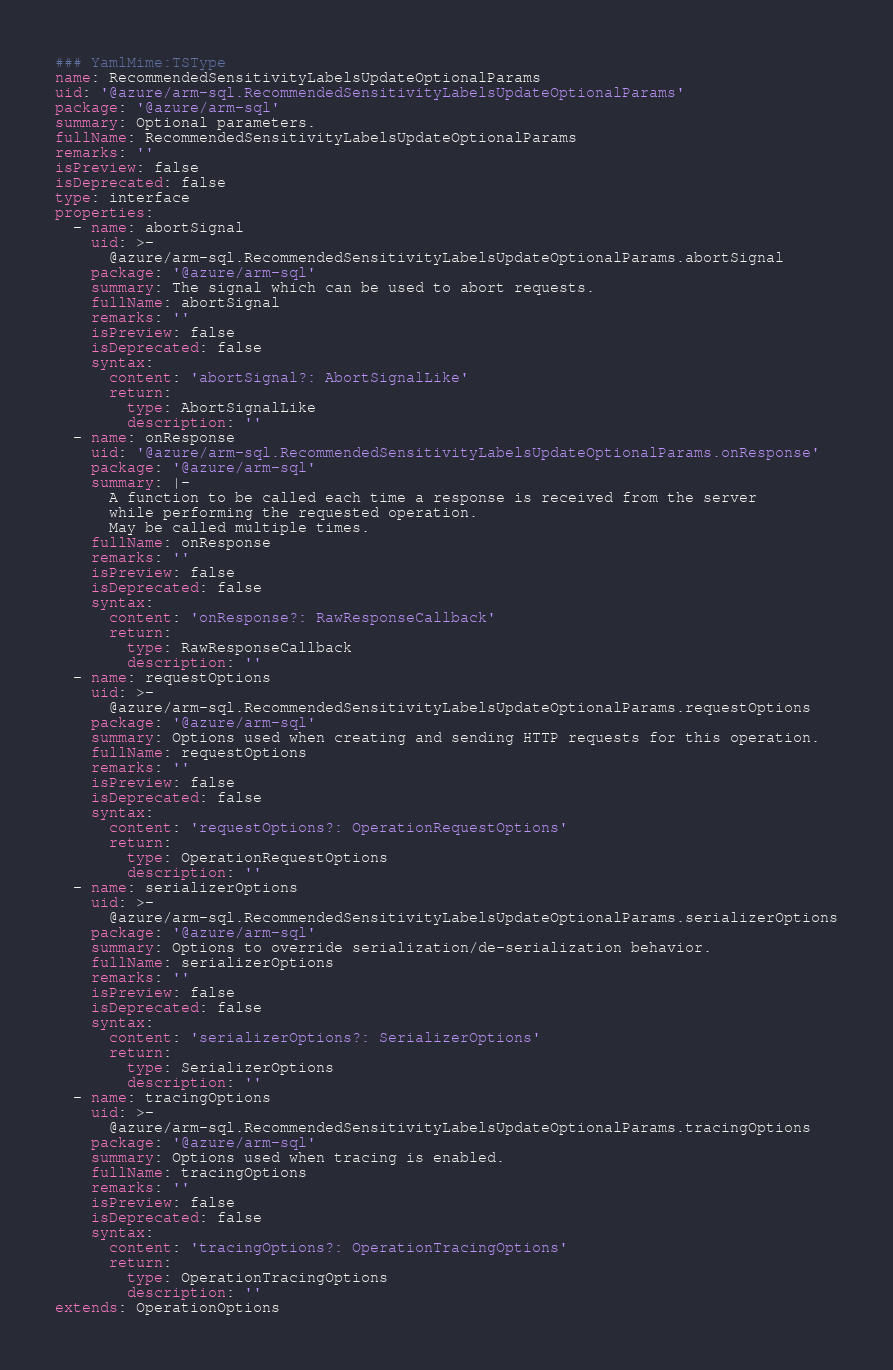<code> <loc_0><loc_0><loc_500><loc_500><_YAML_>### YamlMime:TSType
name: RecommendedSensitivityLabelsUpdateOptionalParams
uid: '@azure/arm-sql.RecommendedSensitivityLabelsUpdateOptionalParams'
package: '@azure/arm-sql'
summary: Optional parameters.
fullName: RecommendedSensitivityLabelsUpdateOptionalParams
remarks: ''
isPreview: false
isDeprecated: false
type: interface
properties:
  - name: abortSignal
    uid: >-
      @azure/arm-sql.RecommendedSensitivityLabelsUpdateOptionalParams.abortSignal
    package: '@azure/arm-sql'
    summary: The signal which can be used to abort requests.
    fullName: abortSignal
    remarks: ''
    isPreview: false
    isDeprecated: false
    syntax:
      content: 'abortSignal?: AbortSignalLike'
      return:
        type: AbortSignalLike
        description: ''
  - name: onResponse
    uid: '@azure/arm-sql.RecommendedSensitivityLabelsUpdateOptionalParams.onResponse'
    package: '@azure/arm-sql'
    summary: |-
      A function to be called each time a response is received from the server
      while performing the requested operation.
      May be called multiple times.
    fullName: onResponse
    remarks: ''
    isPreview: false
    isDeprecated: false
    syntax:
      content: 'onResponse?: RawResponseCallback'
      return:
        type: RawResponseCallback
        description: ''
  - name: requestOptions
    uid: >-
      @azure/arm-sql.RecommendedSensitivityLabelsUpdateOptionalParams.requestOptions
    package: '@azure/arm-sql'
    summary: Options used when creating and sending HTTP requests for this operation.
    fullName: requestOptions
    remarks: ''
    isPreview: false
    isDeprecated: false
    syntax:
      content: 'requestOptions?: OperationRequestOptions'
      return:
        type: OperationRequestOptions
        description: ''
  - name: serializerOptions
    uid: >-
      @azure/arm-sql.RecommendedSensitivityLabelsUpdateOptionalParams.serializerOptions
    package: '@azure/arm-sql'
    summary: Options to override serialization/de-serialization behavior.
    fullName: serializerOptions
    remarks: ''
    isPreview: false
    isDeprecated: false
    syntax:
      content: 'serializerOptions?: SerializerOptions'
      return:
        type: SerializerOptions
        description: ''
  - name: tracingOptions
    uid: >-
      @azure/arm-sql.RecommendedSensitivityLabelsUpdateOptionalParams.tracingOptions
    package: '@azure/arm-sql'
    summary: Options used when tracing is enabled.
    fullName: tracingOptions
    remarks: ''
    isPreview: false
    isDeprecated: false
    syntax:
      content: 'tracingOptions?: OperationTracingOptions'
      return:
        type: OperationTracingOptions
        description: ''
extends: OperationOptions
</code> 